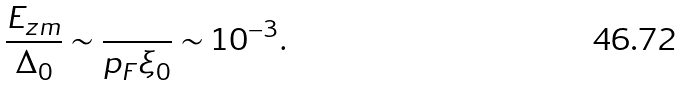<formula> <loc_0><loc_0><loc_500><loc_500>\frac { E _ { z m } } { \Delta _ { 0 } } \sim \frac { } { p _ { F } \xi _ { 0 } } \sim 1 0 ^ { - 3 } .</formula> 